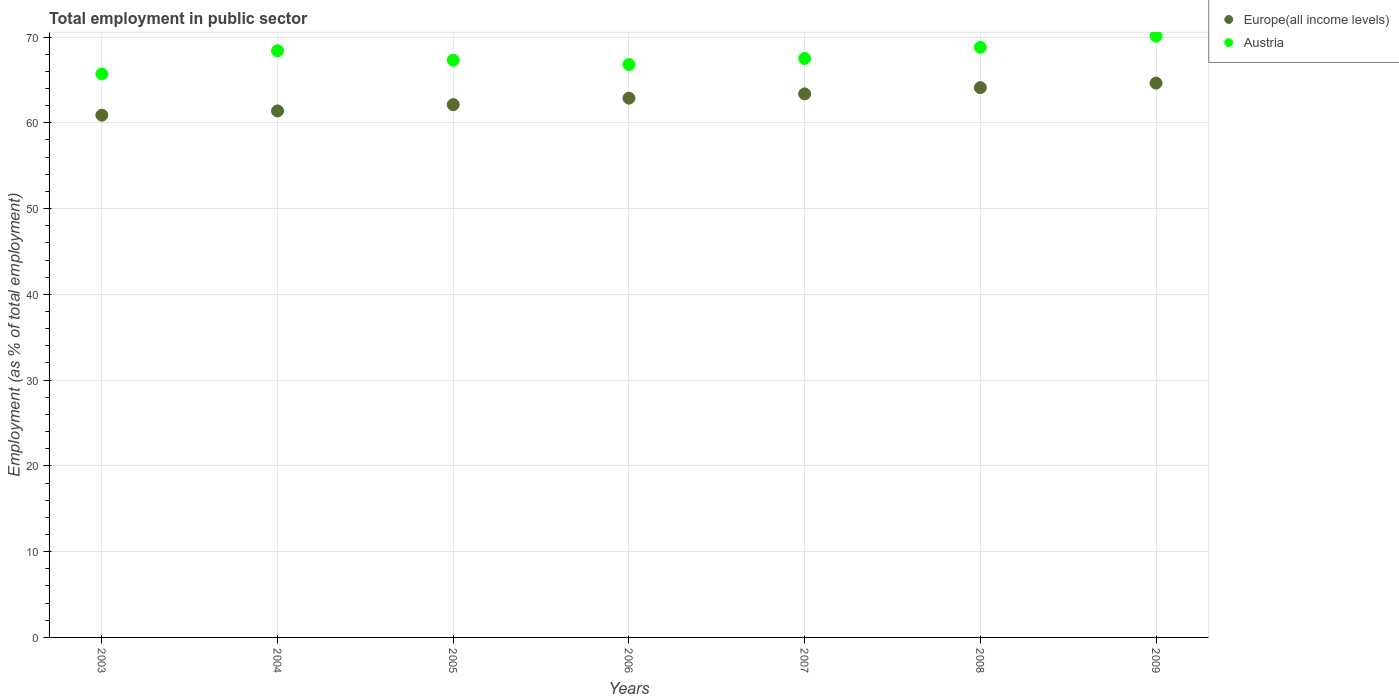How many different coloured dotlines are there?
Ensure brevity in your answer.  2. What is the employment in public sector in Austria in 2006?
Offer a terse response. 66.8. Across all years, what is the maximum employment in public sector in Austria?
Your answer should be very brief. 70.1. Across all years, what is the minimum employment in public sector in Austria?
Your answer should be very brief. 65.7. In which year was the employment in public sector in Europe(all income levels) maximum?
Your answer should be very brief. 2009. In which year was the employment in public sector in Europe(all income levels) minimum?
Keep it short and to the point. 2003. What is the total employment in public sector in Europe(all income levels) in the graph?
Provide a succinct answer. 439.38. What is the difference between the employment in public sector in Europe(all income levels) in 2003 and that in 2006?
Make the answer very short. -1.98. What is the difference between the employment in public sector in Austria in 2003 and the employment in public sector in Europe(all income levels) in 2005?
Ensure brevity in your answer.  3.58. What is the average employment in public sector in Austria per year?
Offer a very short reply. 67.8. In the year 2007, what is the difference between the employment in public sector in Austria and employment in public sector in Europe(all income levels)?
Your answer should be compact. 4.13. What is the ratio of the employment in public sector in Europe(all income levels) in 2004 to that in 2009?
Provide a short and direct response. 0.95. What is the difference between the highest and the second highest employment in public sector in Europe(all income levels)?
Keep it short and to the point. 0.53. What is the difference between the highest and the lowest employment in public sector in Europe(all income levels)?
Your answer should be compact. 3.74. Is the sum of the employment in public sector in Europe(all income levels) in 2003 and 2009 greater than the maximum employment in public sector in Austria across all years?
Provide a succinct answer. Yes. Is the employment in public sector in Europe(all income levels) strictly less than the employment in public sector in Austria over the years?
Offer a terse response. Yes. How many dotlines are there?
Ensure brevity in your answer.  2. What is the difference between two consecutive major ticks on the Y-axis?
Provide a short and direct response. 10. Are the values on the major ticks of Y-axis written in scientific E-notation?
Make the answer very short. No. Does the graph contain any zero values?
Your answer should be compact. No. Does the graph contain grids?
Provide a succinct answer. Yes. Where does the legend appear in the graph?
Ensure brevity in your answer.  Top right. How many legend labels are there?
Offer a terse response. 2. How are the legend labels stacked?
Offer a very short reply. Vertical. What is the title of the graph?
Ensure brevity in your answer.  Total employment in public sector. What is the label or title of the X-axis?
Keep it short and to the point. Years. What is the label or title of the Y-axis?
Make the answer very short. Employment (as % of total employment). What is the Employment (as % of total employment) of Europe(all income levels) in 2003?
Keep it short and to the point. 60.89. What is the Employment (as % of total employment) of Austria in 2003?
Ensure brevity in your answer.  65.7. What is the Employment (as % of total employment) of Europe(all income levels) in 2004?
Your answer should be very brief. 61.39. What is the Employment (as % of total employment) of Austria in 2004?
Provide a short and direct response. 68.4. What is the Employment (as % of total employment) in Europe(all income levels) in 2005?
Provide a short and direct response. 62.12. What is the Employment (as % of total employment) of Austria in 2005?
Offer a very short reply. 67.3. What is the Employment (as % of total employment) of Europe(all income levels) in 2006?
Your response must be concise. 62.87. What is the Employment (as % of total employment) of Austria in 2006?
Your response must be concise. 66.8. What is the Employment (as % of total employment) of Europe(all income levels) in 2007?
Offer a terse response. 63.37. What is the Employment (as % of total employment) in Austria in 2007?
Your answer should be compact. 67.5. What is the Employment (as % of total employment) of Europe(all income levels) in 2008?
Your response must be concise. 64.1. What is the Employment (as % of total employment) in Austria in 2008?
Offer a very short reply. 68.8. What is the Employment (as % of total employment) in Europe(all income levels) in 2009?
Offer a very short reply. 64.63. What is the Employment (as % of total employment) of Austria in 2009?
Ensure brevity in your answer.  70.1. Across all years, what is the maximum Employment (as % of total employment) in Europe(all income levels)?
Your answer should be compact. 64.63. Across all years, what is the maximum Employment (as % of total employment) of Austria?
Keep it short and to the point. 70.1. Across all years, what is the minimum Employment (as % of total employment) of Europe(all income levels)?
Make the answer very short. 60.89. Across all years, what is the minimum Employment (as % of total employment) in Austria?
Offer a very short reply. 65.7. What is the total Employment (as % of total employment) in Europe(all income levels) in the graph?
Offer a very short reply. 439.38. What is the total Employment (as % of total employment) of Austria in the graph?
Offer a very short reply. 474.6. What is the difference between the Employment (as % of total employment) in Europe(all income levels) in 2003 and that in 2004?
Keep it short and to the point. -0.5. What is the difference between the Employment (as % of total employment) in Austria in 2003 and that in 2004?
Offer a terse response. -2.7. What is the difference between the Employment (as % of total employment) of Europe(all income levels) in 2003 and that in 2005?
Provide a short and direct response. -1.23. What is the difference between the Employment (as % of total employment) in Austria in 2003 and that in 2005?
Your answer should be very brief. -1.6. What is the difference between the Employment (as % of total employment) in Europe(all income levels) in 2003 and that in 2006?
Provide a succinct answer. -1.98. What is the difference between the Employment (as % of total employment) in Europe(all income levels) in 2003 and that in 2007?
Provide a succinct answer. -2.48. What is the difference between the Employment (as % of total employment) of Austria in 2003 and that in 2007?
Make the answer very short. -1.8. What is the difference between the Employment (as % of total employment) of Europe(all income levels) in 2003 and that in 2008?
Offer a very short reply. -3.21. What is the difference between the Employment (as % of total employment) in Europe(all income levels) in 2003 and that in 2009?
Provide a succinct answer. -3.74. What is the difference between the Employment (as % of total employment) of Europe(all income levels) in 2004 and that in 2005?
Your response must be concise. -0.74. What is the difference between the Employment (as % of total employment) of Europe(all income levels) in 2004 and that in 2006?
Your response must be concise. -1.49. What is the difference between the Employment (as % of total employment) in Europe(all income levels) in 2004 and that in 2007?
Provide a short and direct response. -1.99. What is the difference between the Employment (as % of total employment) in Europe(all income levels) in 2004 and that in 2008?
Your response must be concise. -2.72. What is the difference between the Employment (as % of total employment) of Austria in 2004 and that in 2008?
Your answer should be compact. -0.4. What is the difference between the Employment (as % of total employment) of Europe(all income levels) in 2004 and that in 2009?
Provide a succinct answer. -3.25. What is the difference between the Employment (as % of total employment) in Europe(all income levels) in 2005 and that in 2006?
Provide a succinct answer. -0.75. What is the difference between the Employment (as % of total employment) of Europe(all income levels) in 2005 and that in 2007?
Keep it short and to the point. -1.25. What is the difference between the Employment (as % of total employment) in Europe(all income levels) in 2005 and that in 2008?
Your response must be concise. -1.98. What is the difference between the Employment (as % of total employment) in Austria in 2005 and that in 2008?
Ensure brevity in your answer.  -1.5. What is the difference between the Employment (as % of total employment) in Europe(all income levels) in 2005 and that in 2009?
Your answer should be very brief. -2.51. What is the difference between the Employment (as % of total employment) of Austria in 2005 and that in 2009?
Provide a short and direct response. -2.8. What is the difference between the Employment (as % of total employment) of Europe(all income levels) in 2006 and that in 2007?
Offer a terse response. -0.5. What is the difference between the Employment (as % of total employment) of Austria in 2006 and that in 2007?
Provide a short and direct response. -0.7. What is the difference between the Employment (as % of total employment) of Europe(all income levels) in 2006 and that in 2008?
Give a very brief answer. -1.23. What is the difference between the Employment (as % of total employment) of Austria in 2006 and that in 2008?
Ensure brevity in your answer.  -2. What is the difference between the Employment (as % of total employment) in Europe(all income levels) in 2006 and that in 2009?
Your answer should be very brief. -1.76. What is the difference between the Employment (as % of total employment) of Austria in 2006 and that in 2009?
Your answer should be compact. -3.3. What is the difference between the Employment (as % of total employment) in Europe(all income levels) in 2007 and that in 2008?
Keep it short and to the point. -0.73. What is the difference between the Employment (as % of total employment) in Austria in 2007 and that in 2008?
Your answer should be compact. -1.3. What is the difference between the Employment (as % of total employment) of Europe(all income levels) in 2007 and that in 2009?
Offer a very short reply. -1.26. What is the difference between the Employment (as % of total employment) of Austria in 2007 and that in 2009?
Keep it short and to the point. -2.6. What is the difference between the Employment (as % of total employment) in Europe(all income levels) in 2008 and that in 2009?
Offer a very short reply. -0.53. What is the difference between the Employment (as % of total employment) in Austria in 2008 and that in 2009?
Your response must be concise. -1.3. What is the difference between the Employment (as % of total employment) in Europe(all income levels) in 2003 and the Employment (as % of total employment) in Austria in 2004?
Provide a succinct answer. -7.51. What is the difference between the Employment (as % of total employment) in Europe(all income levels) in 2003 and the Employment (as % of total employment) in Austria in 2005?
Your response must be concise. -6.41. What is the difference between the Employment (as % of total employment) of Europe(all income levels) in 2003 and the Employment (as % of total employment) of Austria in 2006?
Keep it short and to the point. -5.91. What is the difference between the Employment (as % of total employment) in Europe(all income levels) in 2003 and the Employment (as % of total employment) in Austria in 2007?
Offer a very short reply. -6.61. What is the difference between the Employment (as % of total employment) of Europe(all income levels) in 2003 and the Employment (as % of total employment) of Austria in 2008?
Give a very brief answer. -7.91. What is the difference between the Employment (as % of total employment) of Europe(all income levels) in 2003 and the Employment (as % of total employment) of Austria in 2009?
Ensure brevity in your answer.  -9.21. What is the difference between the Employment (as % of total employment) of Europe(all income levels) in 2004 and the Employment (as % of total employment) of Austria in 2005?
Your answer should be compact. -5.91. What is the difference between the Employment (as % of total employment) of Europe(all income levels) in 2004 and the Employment (as % of total employment) of Austria in 2006?
Your answer should be compact. -5.41. What is the difference between the Employment (as % of total employment) in Europe(all income levels) in 2004 and the Employment (as % of total employment) in Austria in 2007?
Provide a short and direct response. -6.11. What is the difference between the Employment (as % of total employment) of Europe(all income levels) in 2004 and the Employment (as % of total employment) of Austria in 2008?
Ensure brevity in your answer.  -7.41. What is the difference between the Employment (as % of total employment) of Europe(all income levels) in 2004 and the Employment (as % of total employment) of Austria in 2009?
Make the answer very short. -8.71. What is the difference between the Employment (as % of total employment) of Europe(all income levels) in 2005 and the Employment (as % of total employment) of Austria in 2006?
Your answer should be very brief. -4.68. What is the difference between the Employment (as % of total employment) of Europe(all income levels) in 2005 and the Employment (as % of total employment) of Austria in 2007?
Provide a succinct answer. -5.38. What is the difference between the Employment (as % of total employment) in Europe(all income levels) in 2005 and the Employment (as % of total employment) in Austria in 2008?
Ensure brevity in your answer.  -6.68. What is the difference between the Employment (as % of total employment) in Europe(all income levels) in 2005 and the Employment (as % of total employment) in Austria in 2009?
Provide a succinct answer. -7.98. What is the difference between the Employment (as % of total employment) in Europe(all income levels) in 2006 and the Employment (as % of total employment) in Austria in 2007?
Your response must be concise. -4.63. What is the difference between the Employment (as % of total employment) in Europe(all income levels) in 2006 and the Employment (as % of total employment) in Austria in 2008?
Give a very brief answer. -5.93. What is the difference between the Employment (as % of total employment) of Europe(all income levels) in 2006 and the Employment (as % of total employment) of Austria in 2009?
Offer a terse response. -7.23. What is the difference between the Employment (as % of total employment) in Europe(all income levels) in 2007 and the Employment (as % of total employment) in Austria in 2008?
Your answer should be very brief. -5.43. What is the difference between the Employment (as % of total employment) of Europe(all income levels) in 2007 and the Employment (as % of total employment) of Austria in 2009?
Provide a short and direct response. -6.73. What is the difference between the Employment (as % of total employment) in Europe(all income levels) in 2008 and the Employment (as % of total employment) in Austria in 2009?
Your answer should be compact. -6. What is the average Employment (as % of total employment) in Europe(all income levels) per year?
Your answer should be compact. 62.77. What is the average Employment (as % of total employment) of Austria per year?
Offer a terse response. 67.8. In the year 2003, what is the difference between the Employment (as % of total employment) of Europe(all income levels) and Employment (as % of total employment) of Austria?
Ensure brevity in your answer.  -4.81. In the year 2004, what is the difference between the Employment (as % of total employment) in Europe(all income levels) and Employment (as % of total employment) in Austria?
Your answer should be compact. -7.01. In the year 2005, what is the difference between the Employment (as % of total employment) in Europe(all income levels) and Employment (as % of total employment) in Austria?
Your response must be concise. -5.18. In the year 2006, what is the difference between the Employment (as % of total employment) in Europe(all income levels) and Employment (as % of total employment) in Austria?
Keep it short and to the point. -3.93. In the year 2007, what is the difference between the Employment (as % of total employment) of Europe(all income levels) and Employment (as % of total employment) of Austria?
Your answer should be compact. -4.13. In the year 2008, what is the difference between the Employment (as % of total employment) in Europe(all income levels) and Employment (as % of total employment) in Austria?
Make the answer very short. -4.7. In the year 2009, what is the difference between the Employment (as % of total employment) in Europe(all income levels) and Employment (as % of total employment) in Austria?
Your answer should be very brief. -5.47. What is the ratio of the Employment (as % of total employment) in Austria in 2003 to that in 2004?
Your answer should be compact. 0.96. What is the ratio of the Employment (as % of total employment) in Europe(all income levels) in 2003 to that in 2005?
Provide a short and direct response. 0.98. What is the ratio of the Employment (as % of total employment) in Austria in 2003 to that in 2005?
Your response must be concise. 0.98. What is the ratio of the Employment (as % of total employment) in Europe(all income levels) in 2003 to that in 2006?
Your answer should be compact. 0.97. What is the ratio of the Employment (as % of total employment) in Austria in 2003 to that in 2006?
Provide a short and direct response. 0.98. What is the ratio of the Employment (as % of total employment) of Europe(all income levels) in 2003 to that in 2007?
Ensure brevity in your answer.  0.96. What is the ratio of the Employment (as % of total employment) in Austria in 2003 to that in 2007?
Provide a succinct answer. 0.97. What is the ratio of the Employment (as % of total employment) in Europe(all income levels) in 2003 to that in 2008?
Provide a short and direct response. 0.95. What is the ratio of the Employment (as % of total employment) of Austria in 2003 to that in 2008?
Your answer should be very brief. 0.95. What is the ratio of the Employment (as % of total employment) of Europe(all income levels) in 2003 to that in 2009?
Keep it short and to the point. 0.94. What is the ratio of the Employment (as % of total employment) of Austria in 2003 to that in 2009?
Offer a terse response. 0.94. What is the ratio of the Employment (as % of total employment) in Austria in 2004 to that in 2005?
Offer a terse response. 1.02. What is the ratio of the Employment (as % of total employment) of Europe(all income levels) in 2004 to that in 2006?
Your response must be concise. 0.98. What is the ratio of the Employment (as % of total employment) of Austria in 2004 to that in 2006?
Make the answer very short. 1.02. What is the ratio of the Employment (as % of total employment) of Europe(all income levels) in 2004 to that in 2007?
Ensure brevity in your answer.  0.97. What is the ratio of the Employment (as % of total employment) of Austria in 2004 to that in 2007?
Make the answer very short. 1.01. What is the ratio of the Employment (as % of total employment) in Europe(all income levels) in 2004 to that in 2008?
Offer a terse response. 0.96. What is the ratio of the Employment (as % of total employment) in Austria in 2004 to that in 2008?
Offer a terse response. 0.99. What is the ratio of the Employment (as % of total employment) in Europe(all income levels) in 2004 to that in 2009?
Offer a terse response. 0.95. What is the ratio of the Employment (as % of total employment) of Austria in 2004 to that in 2009?
Ensure brevity in your answer.  0.98. What is the ratio of the Employment (as % of total employment) in Europe(all income levels) in 2005 to that in 2006?
Ensure brevity in your answer.  0.99. What is the ratio of the Employment (as % of total employment) of Austria in 2005 to that in 2006?
Offer a terse response. 1.01. What is the ratio of the Employment (as % of total employment) in Europe(all income levels) in 2005 to that in 2007?
Ensure brevity in your answer.  0.98. What is the ratio of the Employment (as % of total employment) of Austria in 2005 to that in 2007?
Give a very brief answer. 1. What is the ratio of the Employment (as % of total employment) of Europe(all income levels) in 2005 to that in 2008?
Give a very brief answer. 0.97. What is the ratio of the Employment (as % of total employment) in Austria in 2005 to that in 2008?
Provide a succinct answer. 0.98. What is the ratio of the Employment (as % of total employment) in Europe(all income levels) in 2005 to that in 2009?
Provide a succinct answer. 0.96. What is the ratio of the Employment (as % of total employment) in Austria in 2005 to that in 2009?
Your answer should be compact. 0.96. What is the ratio of the Employment (as % of total employment) in Europe(all income levels) in 2006 to that in 2008?
Your answer should be compact. 0.98. What is the ratio of the Employment (as % of total employment) in Austria in 2006 to that in 2008?
Provide a succinct answer. 0.97. What is the ratio of the Employment (as % of total employment) in Europe(all income levels) in 2006 to that in 2009?
Ensure brevity in your answer.  0.97. What is the ratio of the Employment (as % of total employment) of Austria in 2006 to that in 2009?
Ensure brevity in your answer.  0.95. What is the ratio of the Employment (as % of total employment) in Austria in 2007 to that in 2008?
Offer a terse response. 0.98. What is the ratio of the Employment (as % of total employment) in Europe(all income levels) in 2007 to that in 2009?
Your answer should be very brief. 0.98. What is the ratio of the Employment (as % of total employment) of Austria in 2007 to that in 2009?
Offer a very short reply. 0.96. What is the ratio of the Employment (as % of total employment) in Europe(all income levels) in 2008 to that in 2009?
Your answer should be very brief. 0.99. What is the ratio of the Employment (as % of total employment) in Austria in 2008 to that in 2009?
Give a very brief answer. 0.98. What is the difference between the highest and the second highest Employment (as % of total employment) of Europe(all income levels)?
Ensure brevity in your answer.  0.53. What is the difference between the highest and the lowest Employment (as % of total employment) of Europe(all income levels)?
Your answer should be compact. 3.74. What is the difference between the highest and the lowest Employment (as % of total employment) in Austria?
Offer a terse response. 4.4. 